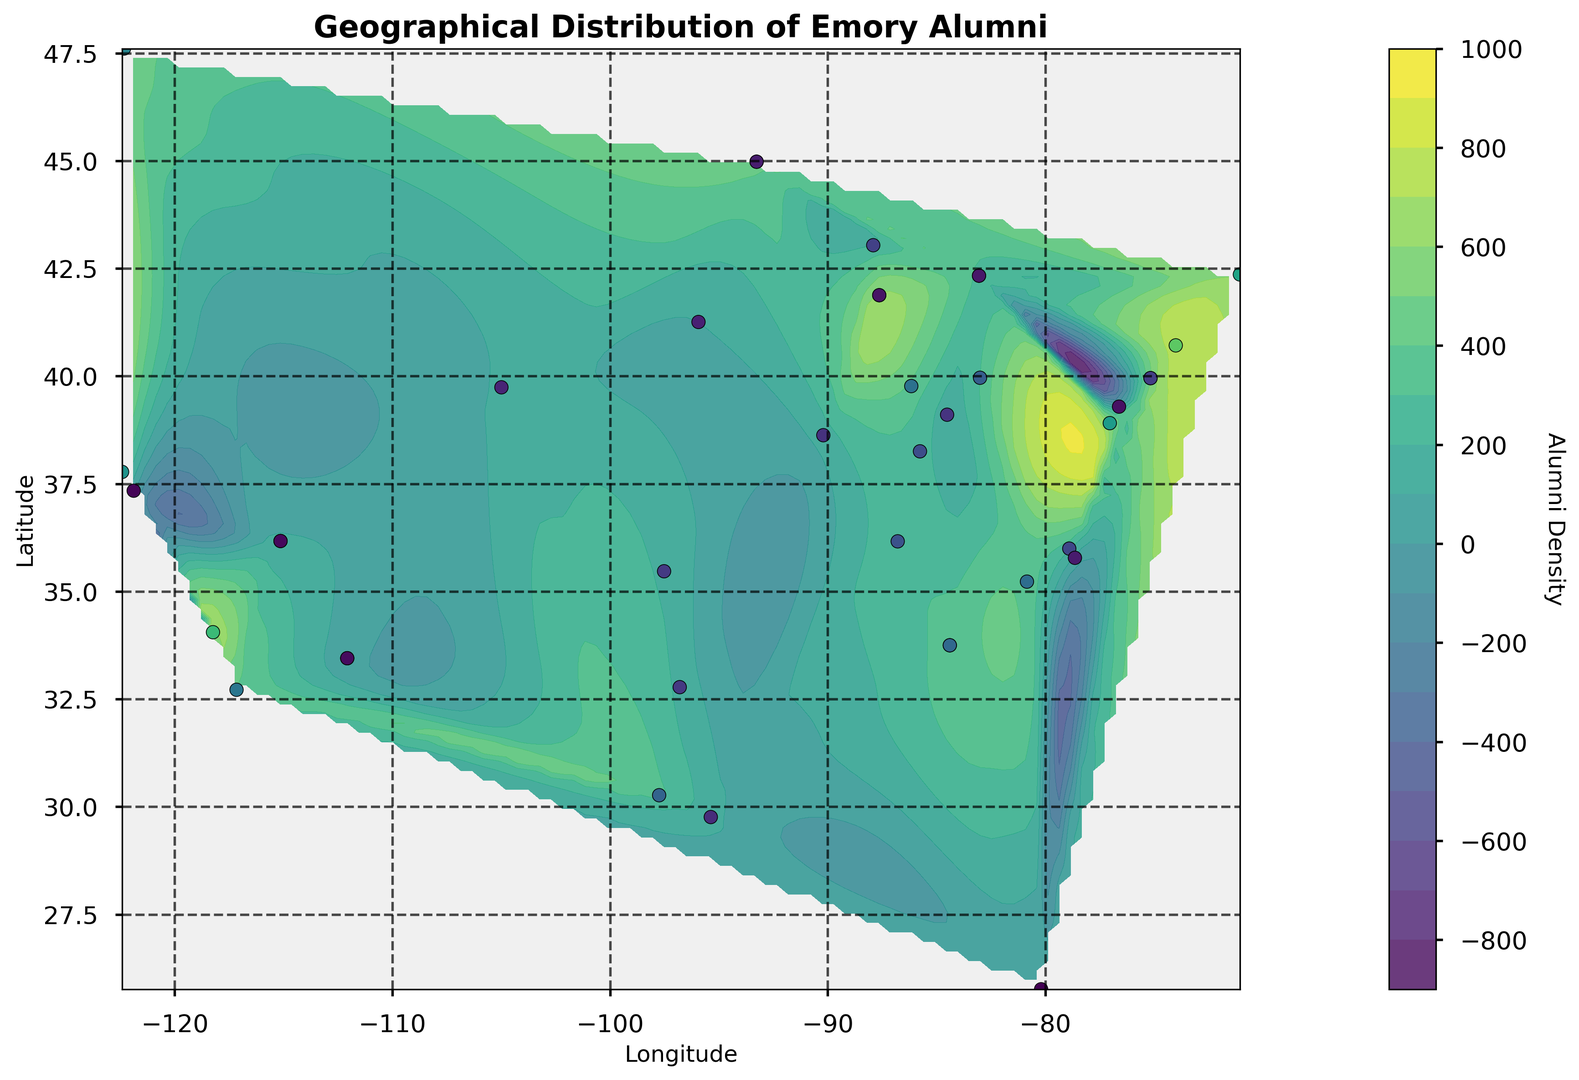What is the highest alumni density shown on the map? The highest alumni density can be identified by looking at the darkest area on the contour plot and locating the corresponding scatter point. The point with the highest density is near Atlanta, GA.
Answer: 1000 Which city has a higher alumni density, New York or Los Angeles? To determine this, find the points on the map corresponding to New York (Latitude 40.7128, Longitude -74.0060) and Los Angeles (Latitude 34.0522, Longitude -118.2437). Compare the color intensities or the density values at these points.
Answer: New York How does the alumni density in Chicago compare to that in Boston? Locate Chicago (Latitude 41.8781, Longitude -87.6298) and Boston (Latitude 42.3601, Longitude -71.0589) on the contour plot. Compare their color shades or density values.
Answer: Chicago is denser than Boston What is the approximate alumni density in San Francisco? Look for San Francisco’s location (Latitude 37.7749, Longitude -122.4194) on the map. The color intensity or the scatter point's density value would give the density estimate.
Answer: 520 What is the average alumni density in the cities with densities above 500? Identify the cities with densities above 500: Atlanta (1000), New York (750), Los Angeles (680), Chicago (620), and Boston (590). Compute the average: (1000 + 750 + 680 + 620 + 590) / 5 = 728.
Answer: 728 Which region shows a higher diversity of alumni density: the Midwest or the West Coast? Compare the Midwest cities like Chicago, Minneapolis, Indianapolis, etc., with West Coast cities like Los Angeles, San Francisco, and Seattle, by looking at the density values and color variations.
Answer: West Coast Is there any visible trend in alumni distribution along the East Coast? Observe the contour plot along the East Coast from Florida up to the Northeast. Look for any gradient or density clusters indicating higher alumni concentrations.
Answer: Higher density in major cities Between Dallas and Houston, which city has fewer Emory alumni? Locate Dallas (Latitude 32.7767, Longitude -96.7970) and Houston (Latitude 29.7604, Longitude -95.3698) on the map and compare their density values shown in the plot.
Answer: Houston What is the overall color trend from the East Coast to the West Coast? Examine the contour shades moving horizontally from the East Coast to the West Coast. Identify trends in the color gradation, indicating changing alumni densities.
Answer: Density decreases 